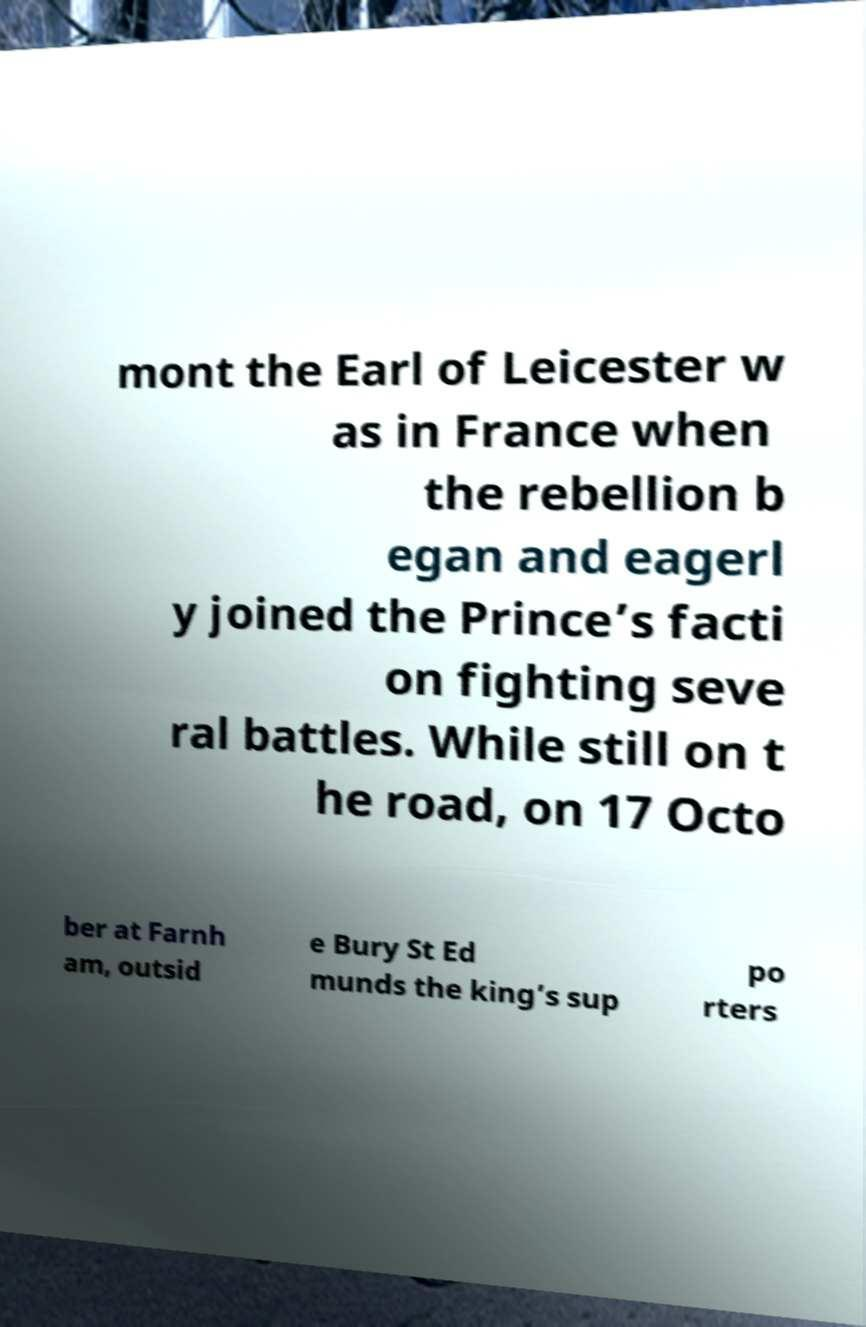Please read and relay the text visible in this image. What does it say? mont the Earl of Leicester w as in France when the rebellion b egan and eagerl y joined the Prince’s facti on fighting seve ral battles. While still on t he road, on 17 Octo ber at Farnh am, outsid e Bury St Ed munds the king’s sup po rters 